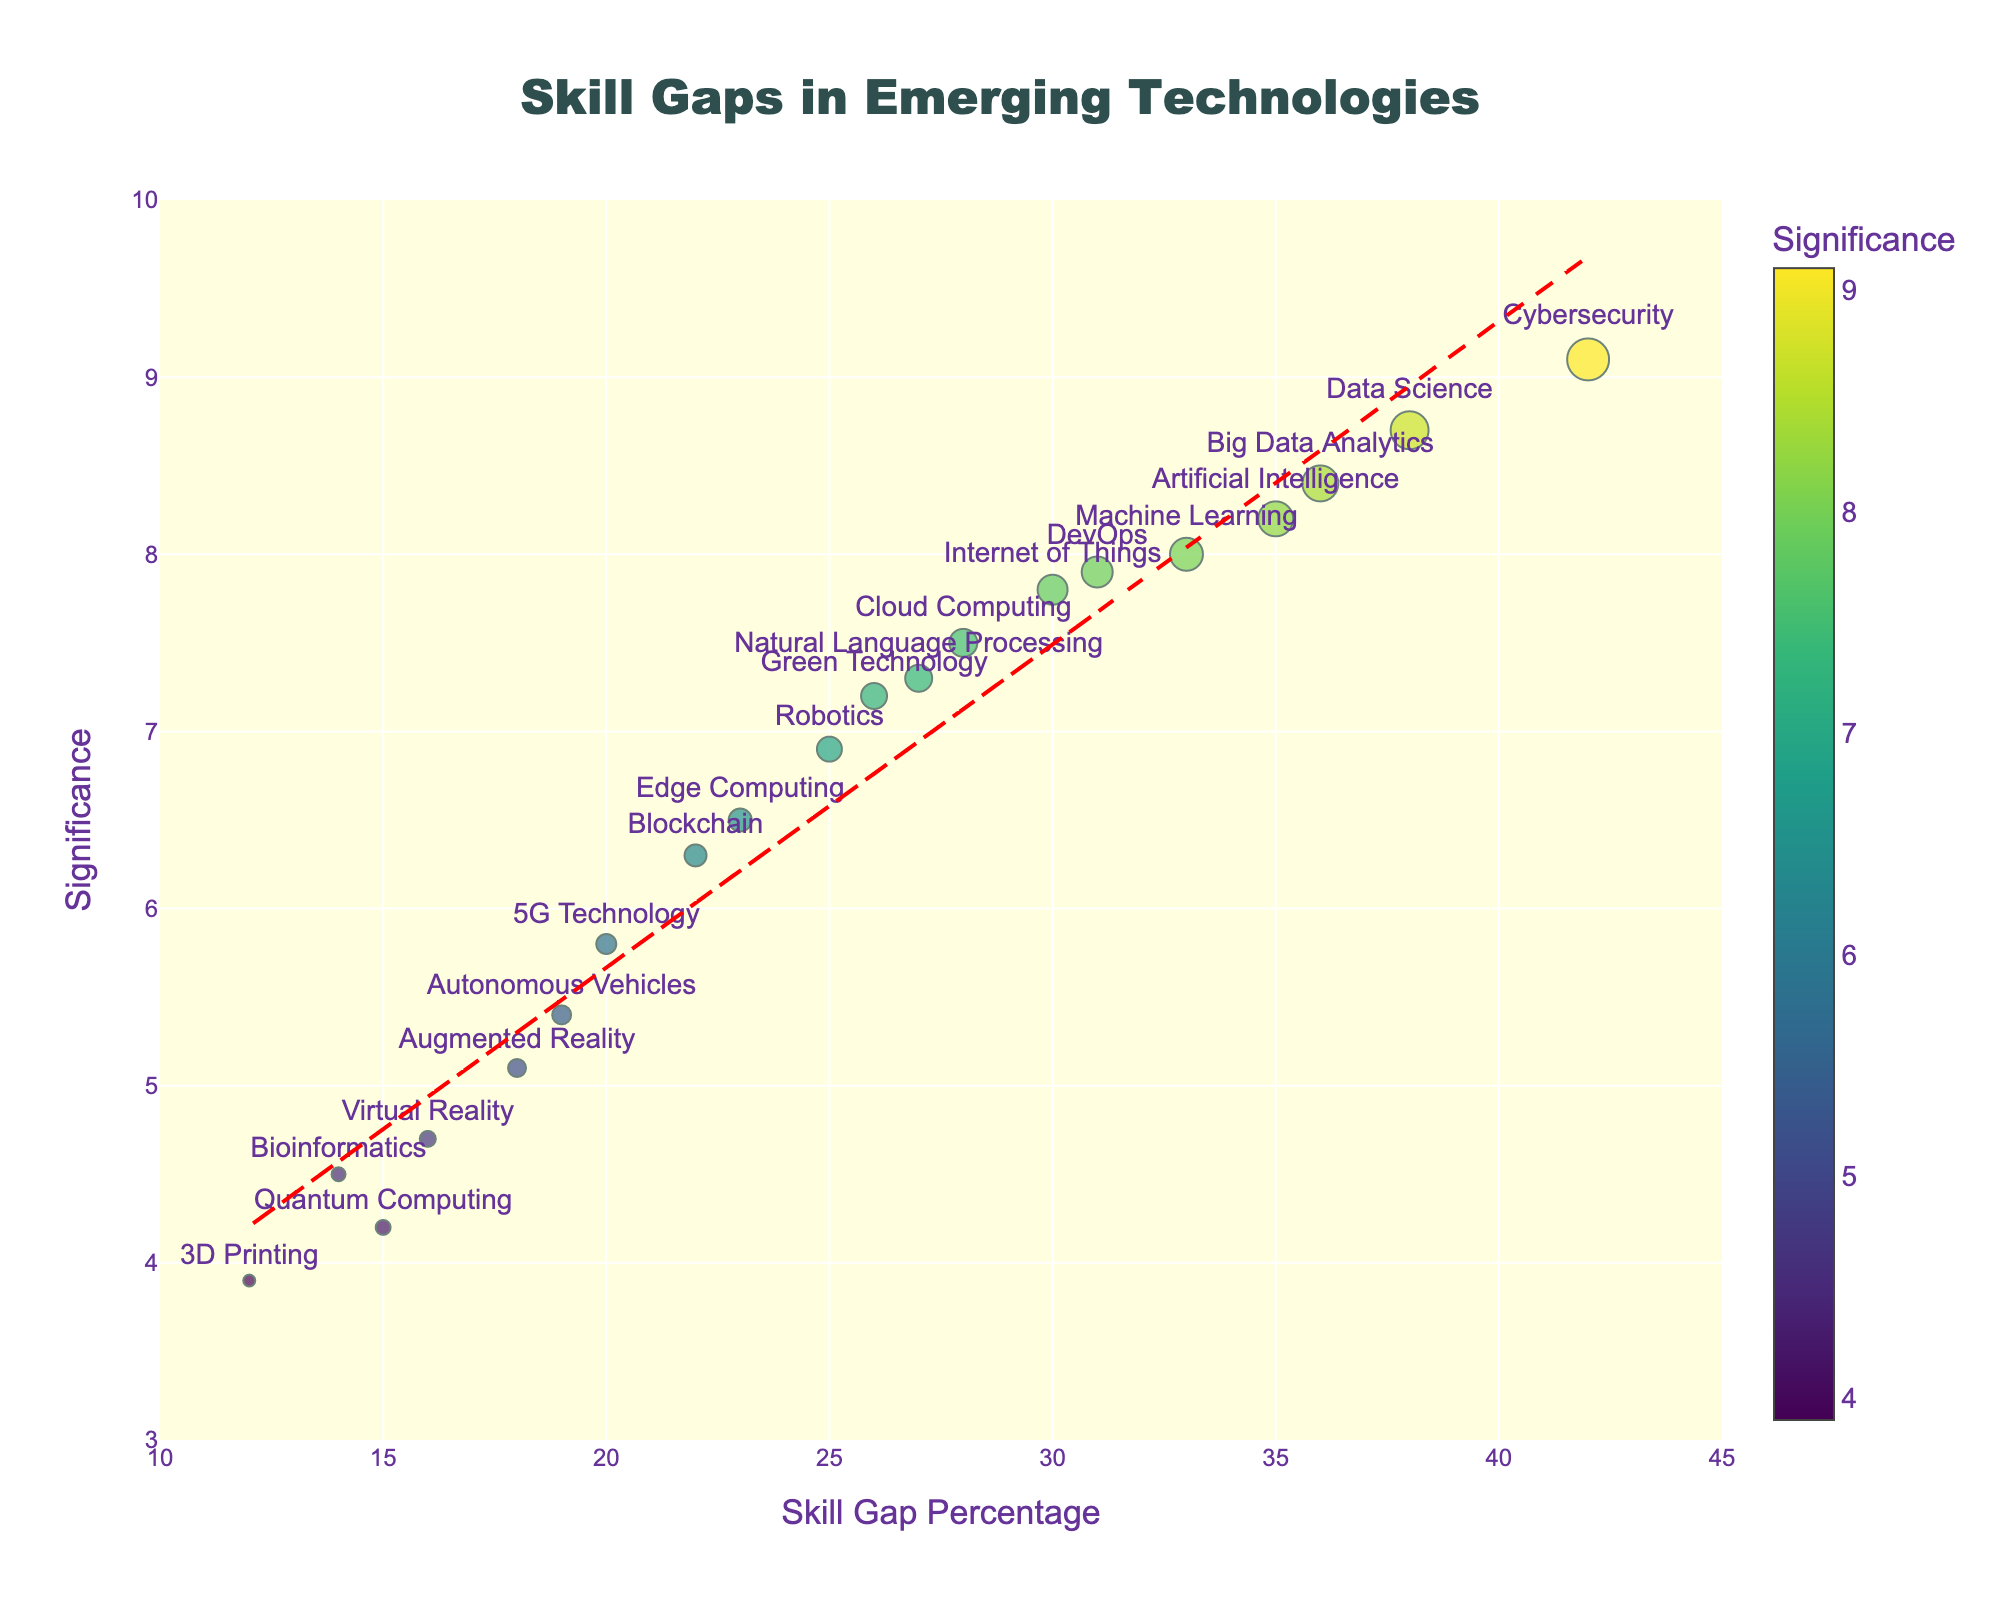What is the title of the plot? The title of the plot is found at the top center of the figure and reads "Skill Gaps in Emerging Technologies."
Answer: Skill Gaps in Emerging Technologies How is the significance of a skill gap represented in the plot? The significance is represented by the color intensity of the markers, as shown by the color scale on the figure.
Answer: Color intensity What skill has the highest gap percentage? By looking at the x-axis, the skill with the highest gap percentage is "Cybersecurity," positioned at 42%.
Answer: Cybersecurity Which skills have a significance value above 8.5? The skills with significance values above 8.5 are "Cybersecurity" (9.1) and "Data Science" (8.7). You can find this by referring to the y-axis values.
Answer: Cybersecurity, Data Science What are the axes titles? The x-axis title is "Skill Gap Percentage" and the y-axis title is "Significance." These titles are displayed along the respective axes.
Answer: Skill Gap Percentage, Significance What is the gap percentage for "Quantum Computing"? By locating "Quantum Computing" in the plot, the gap percentage is found to be 15%.
Answer: 15% Compare the gap percentages of "5G Technology" and "Robotics." Which one is greater? "5G Technology" has a gap percentage of 20%, whereas "Robotics" has a gap percentage of 25%. Therefore, "Robotics" is greater.
Answer: Robotics Between "Artificial Intelligence" and "Big Data Analytics," which has a higher significance? "Artificial Intelligence" has a significance of 8.2, while "Big Data Analytics" has a significance of 8.4. Therefore, "Big Data Analytics" has a higher significance.
Answer: Big Data Analytics Identify three skills that have similar gap percentages but different levels of significance. "Internet of Things" (30%, 7.8), "DevOps" (31%, 7.9), and "Natural Language Processing" (27%, 7.3) all have similar gap percentages but different significance values.
Answer: Internet of Things, DevOps, Natural Language Processing Which skills are below the trend line? Skills below the trend line appear under the red dashed line; notably some of these include "Blockchain," "5G Technology," and "Quantum Computing."
Answer: Blockchain, 5G Technology, Quantum Computing 